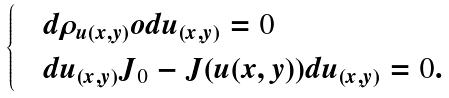Convert formula to latex. <formula><loc_0><loc_0><loc_500><loc_500>\begin{cases} & d \rho _ { u ( x , y ) } o d u _ { ( x , y ) } = 0 \\ & d u _ { ( x , y ) } J _ { 0 } - J ( u ( x , y ) ) d u _ { ( x , y ) } = 0 . \end{cases}</formula> 